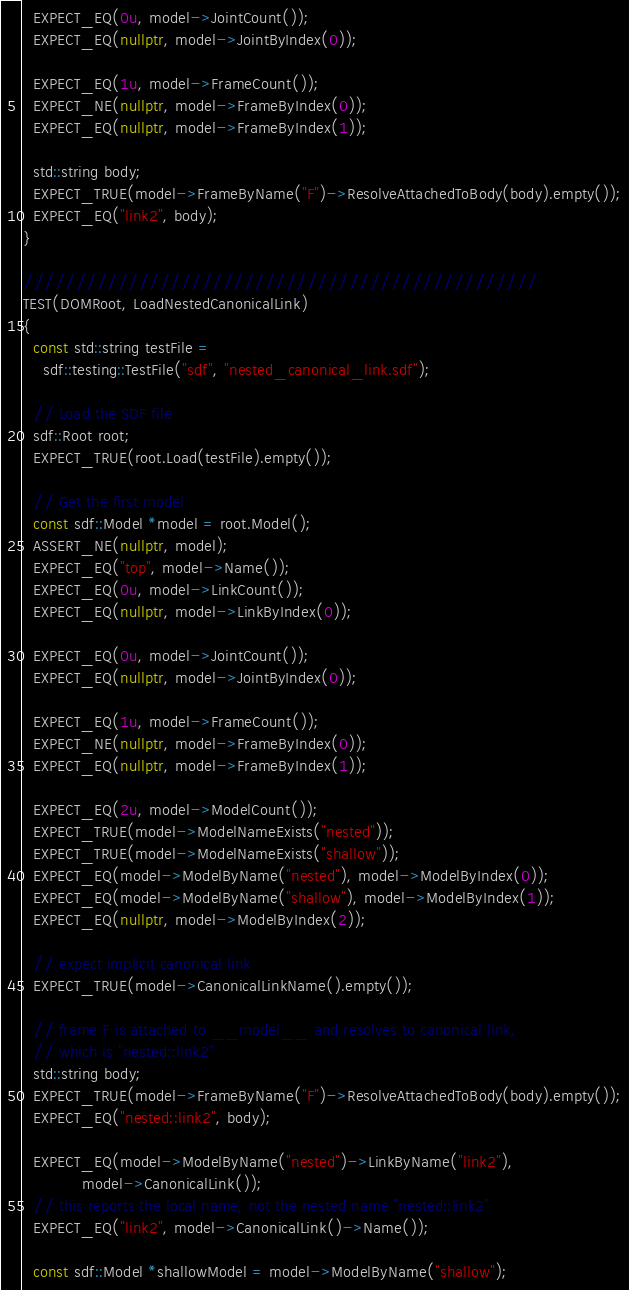Convert code to text. <code><loc_0><loc_0><loc_500><loc_500><_C++_>
  EXPECT_EQ(0u, model->JointCount());
  EXPECT_EQ(nullptr, model->JointByIndex(0));

  EXPECT_EQ(1u, model->FrameCount());
  EXPECT_NE(nullptr, model->FrameByIndex(0));
  EXPECT_EQ(nullptr, model->FrameByIndex(1));

  std::string body;
  EXPECT_TRUE(model->FrameByName("F")->ResolveAttachedToBody(body).empty());
  EXPECT_EQ("link2", body);
}

/////////////////////////////////////////////////
TEST(DOMRoot, LoadNestedCanonicalLink)
{
  const std::string testFile =
    sdf::testing::TestFile("sdf", "nested_canonical_link.sdf");

  // Load the SDF file
  sdf::Root root;
  EXPECT_TRUE(root.Load(testFile).empty());

  // Get the first model
  const sdf::Model *model = root.Model();
  ASSERT_NE(nullptr, model);
  EXPECT_EQ("top", model->Name());
  EXPECT_EQ(0u, model->LinkCount());
  EXPECT_EQ(nullptr, model->LinkByIndex(0));

  EXPECT_EQ(0u, model->JointCount());
  EXPECT_EQ(nullptr, model->JointByIndex(0));

  EXPECT_EQ(1u, model->FrameCount());
  EXPECT_NE(nullptr, model->FrameByIndex(0));
  EXPECT_EQ(nullptr, model->FrameByIndex(1));

  EXPECT_EQ(2u, model->ModelCount());
  EXPECT_TRUE(model->ModelNameExists("nested"));
  EXPECT_TRUE(model->ModelNameExists("shallow"));
  EXPECT_EQ(model->ModelByName("nested"), model->ModelByIndex(0));
  EXPECT_EQ(model->ModelByName("shallow"), model->ModelByIndex(1));
  EXPECT_EQ(nullptr, model->ModelByIndex(2));

  // expect implicit canonical link
  EXPECT_TRUE(model->CanonicalLinkName().empty());

  // frame F is attached to __model__ and resolves to canonical link,
  // which is "nested::link2"
  std::string body;
  EXPECT_TRUE(model->FrameByName("F")->ResolveAttachedToBody(body).empty());
  EXPECT_EQ("nested::link2", body);

  EXPECT_EQ(model->ModelByName("nested")->LinkByName("link2"),
            model->CanonicalLink());
  // this reports the local name, not the nested name "nested::link2"
  EXPECT_EQ("link2", model->CanonicalLink()->Name());

  const sdf::Model *shallowModel = model->ModelByName("shallow");</code> 